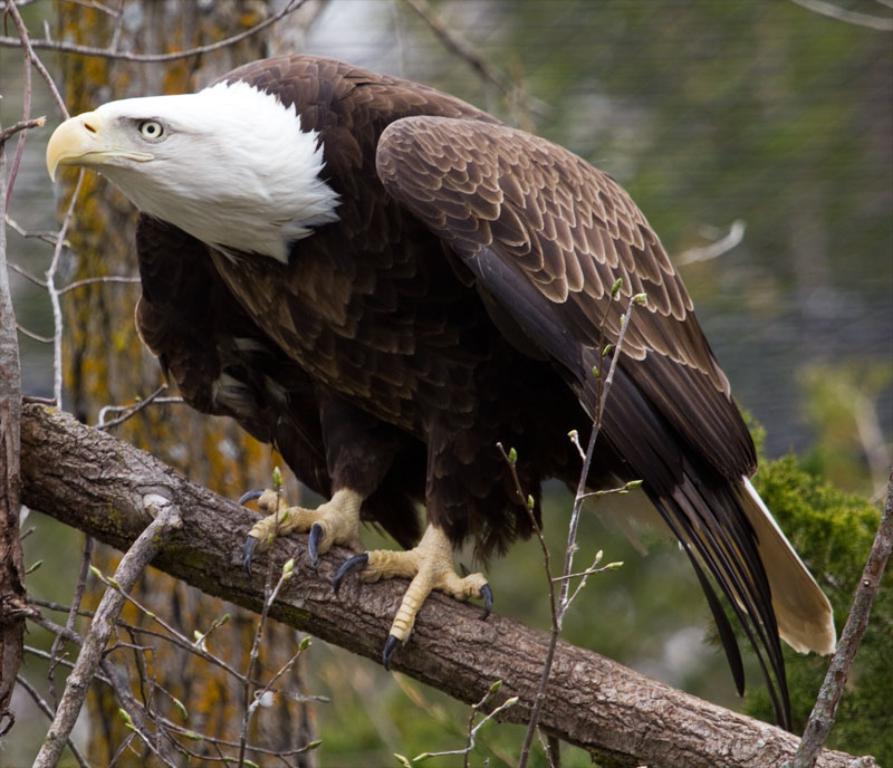Could you give a brief overview of what you see in this image? In this image I can see an eagle is on a tree. Here I can see a tree. The background of the image is blurred. 